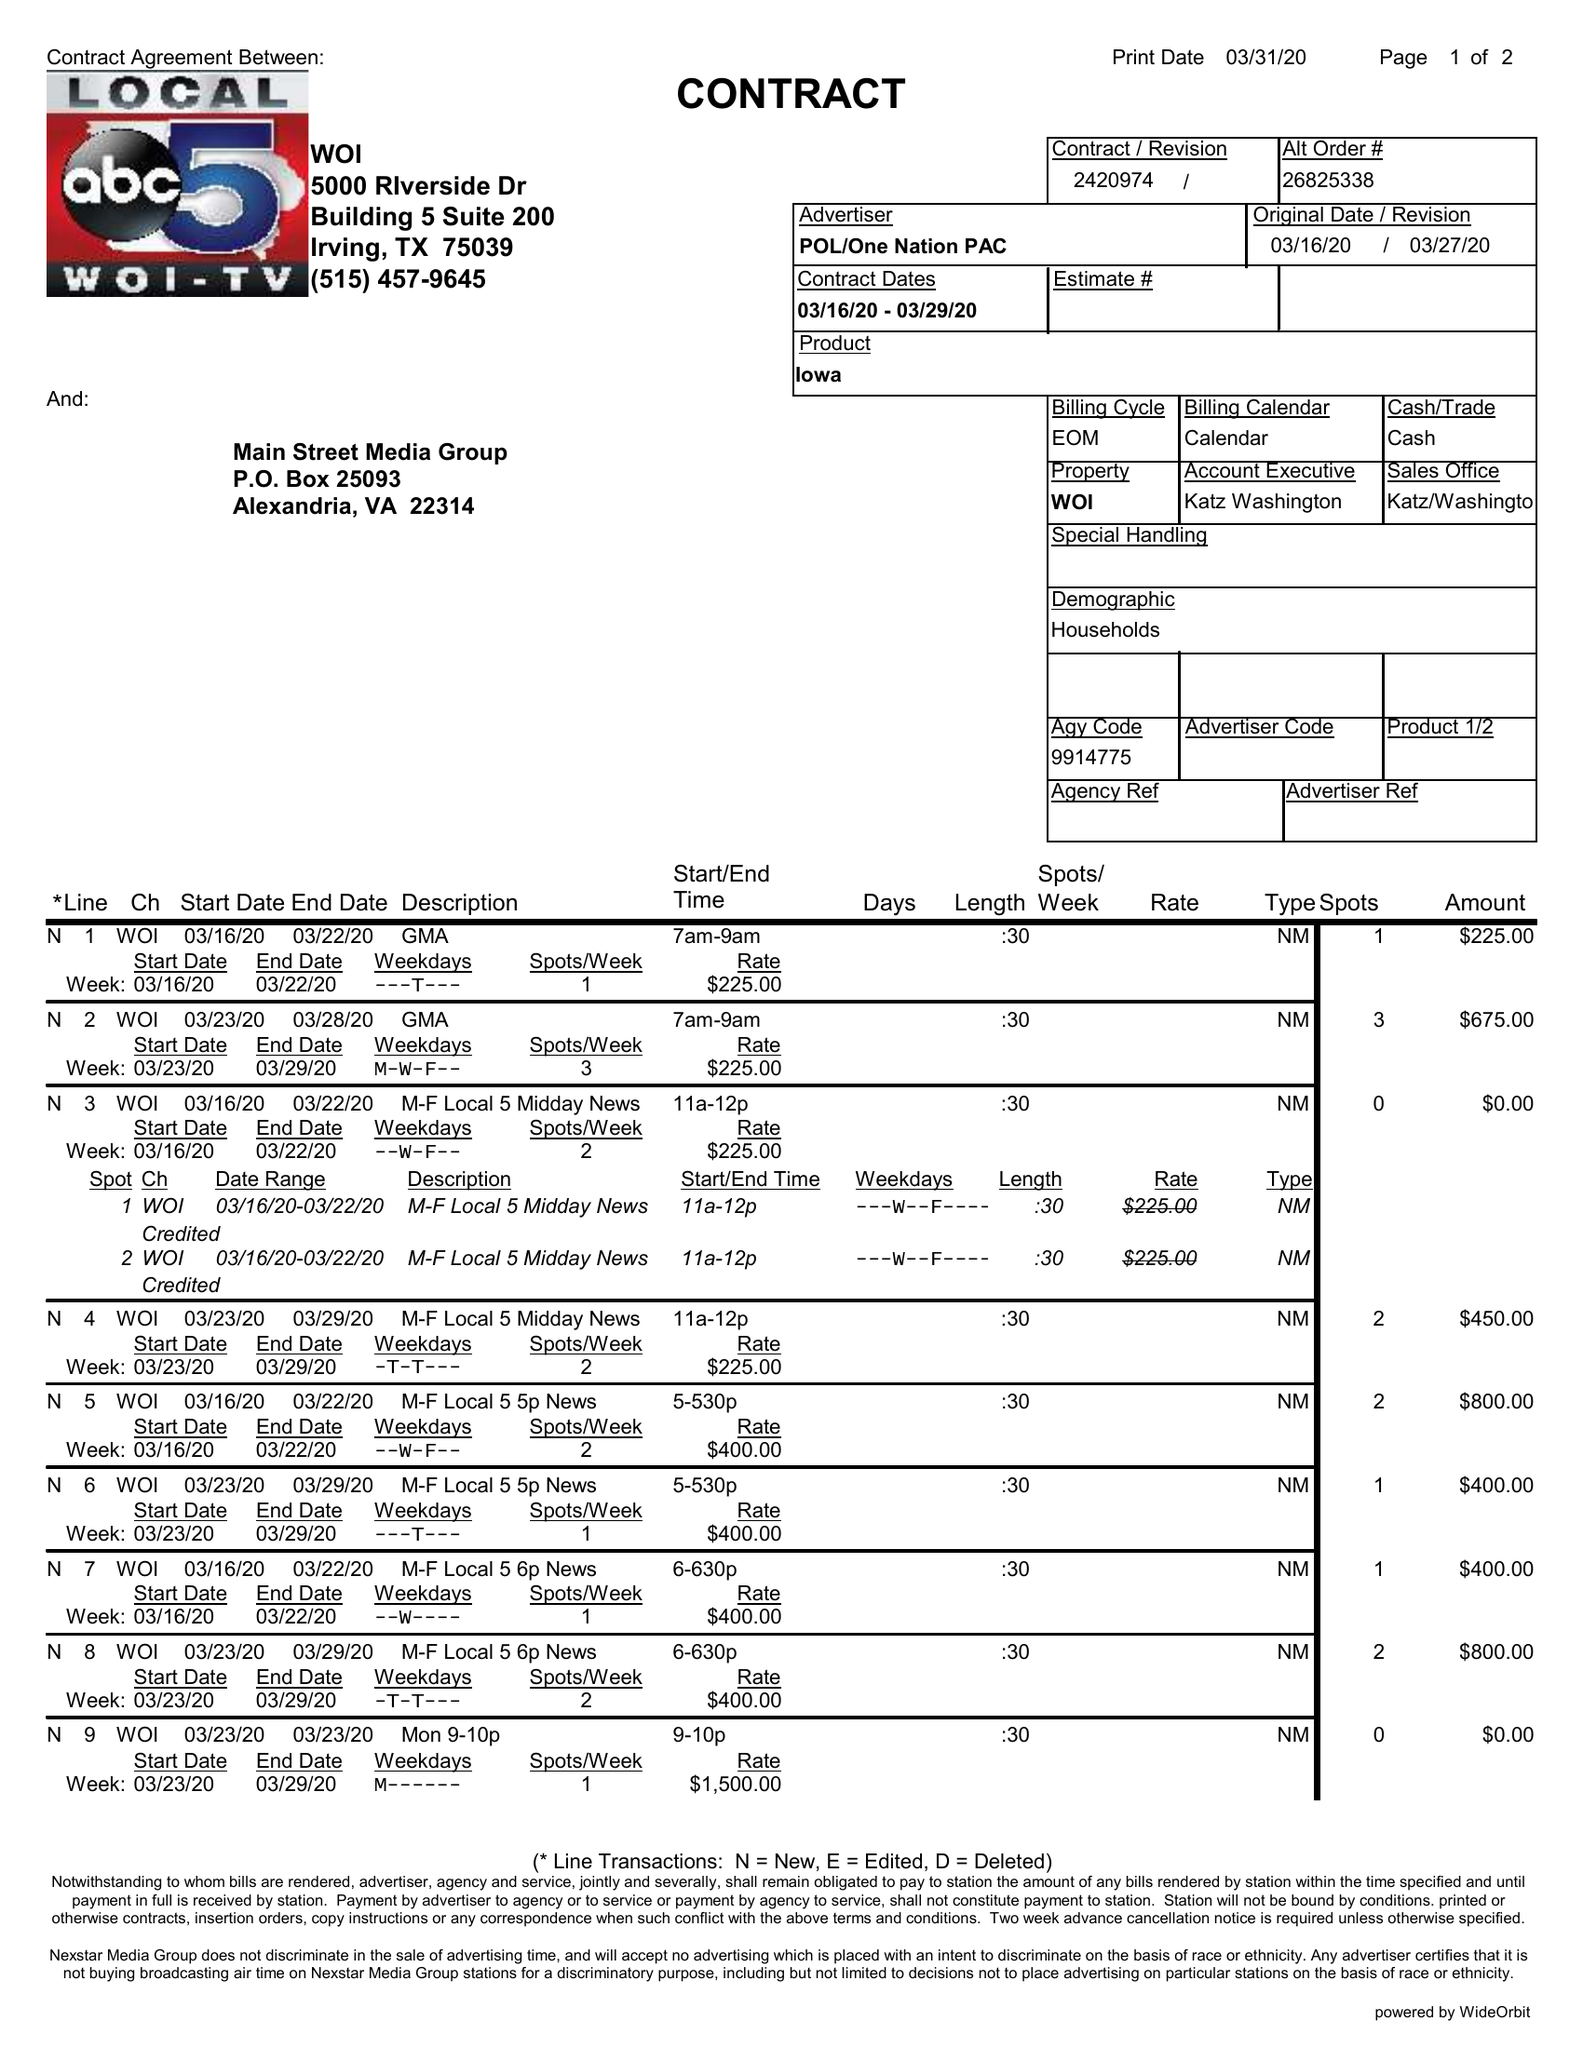What is the value for the contract_num?
Answer the question using a single word or phrase. 2420974 